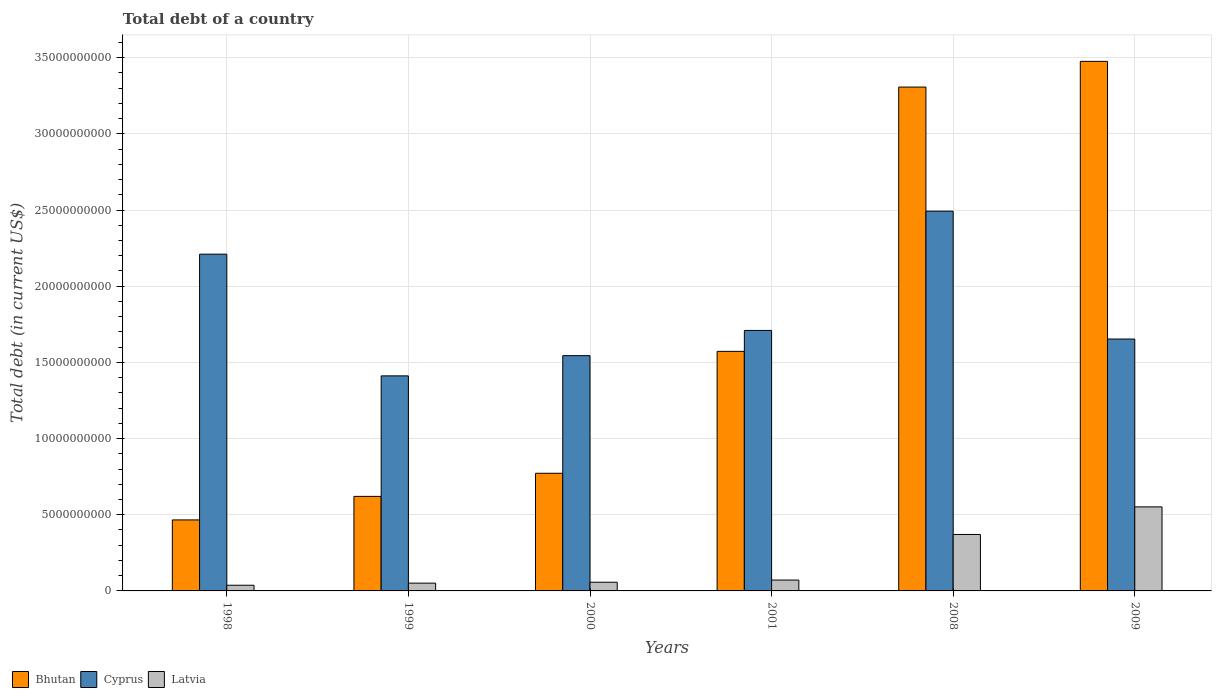How many different coloured bars are there?
Your answer should be very brief. 3. Are the number of bars per tick equal to the number of legend labels?
Your answer should be compact. Yes. How many bars are there on the 1st tick from the left?
Your answer should be compact. 3. How many bars are there on the 4th tick from the right?
Offer a very short reply. 3. What is the debt in Bhutan in 2008?
Keep it short and to the point. 3.31e+1. Across all years, what is the maximum debt in Latvia?
Give a very brief answer. 5.52e+09. Across all years, what is the minimum debt in Bhutan?
Provide a short and direct response. 4.66e+09. In which year was the debt in Bhutan maximum?
Offer a very short reply. 2009. In which year was the debt in Cyprus minimum?
Offer a terse response. 1999. What is the total debt in Bhutan in the graph?
Give a very brief answer. 1.02e+11. What is the difference between the debt in Latvia in 2000 and that in 2001?
Offer a terse response. -1.42e+08. What is the difference between the debt in Latvia in 2001 and the debt in Cyprus in 2009?
Give a very brief answer. -1.58e+1. What is the average debt in Cyprus per year?
Your response must be concise. 1.84e+1. In the year 2008, what is the difference between the debt in Bhutan and debt in Latvia?
Your answer should be compact. 2.94e+1. What is the ratio of the debt in Bhutan in 2001 to that in 2009?
Provide a succinct answer. 0.45. Is the difference between the debt in Bhutan in 2000 and 2001 greater than the difference between the debt in Latvia in 2000 and 2001?
Provide a succinct answer. No. What is the difference between the highest and the second highest debt in Bhutan?
Your answer should be compact. 1.69e+09. What is the difference between the highest and the lowest debt in Latvia?
Offer a very short reply. 5.14e+09. In how many years, is the debt in Cyprus greater than the average debt in Cyprus taken over all years?
Your response must be concise. 2. What does the 1st bar from the left in 2008 represents?
Keep it short and to the point. Bhutan. What does the 2nd bar from the right in 1999 represents?
Your answer should be very brief. Cyprus. How many bars are there?
Your answer should be very brief. 18. Are all the bars in the graph horizontal?
Make the answer very short. No. What is the difference between two consecutive major ticks on the Y-axis?
Make the answer very short. 5.00e+09. Does the graph contain any zero values?
Keep it short and to the point. No. Where does the legend appear in the graph?
Your answer should be very brief. Bottom left. How many legend labels are there?
Make the answer very short. 3. How are the legend labels stacked?
Provide a short and direct response. Horizontal. What is the title of the graph?
Ensure brevity in your answer.  Total debt of a country. What is the label or title of the Y-axis?
Your answer should be very brief. Total debt (in current US$). What is the Total debt (in current US$) of Bhutan in 1998?
Ensure brevity in your answer.  4.66e+09. What is the Total debt (in current US$) of Cyprus in 1998?
Keep it short and to the point. 2.21e+1. What is the Total debt (in current US$) of Latvia in 1998?
Give a very brief answer. 3.73e+08. What is the Total debt (in current US$) of Bhutan in 1999?
Offer a very short reply. 6.21e+09. What is the Total debt (in current US$) in Cyprus in 1999?
Provide a succinct answer. 1.41e+1. What is the Total debt (in current US$) of Latvia in 1999?
Your response must be concise. 5.11e+08. What is the Total debt (in current US$) in Bhutan in 2000?
Provide a short and direct response. 7.72e+09. What is the Total debt (in current US$) in Cyprus in 2000?
Provide a short and direct response. 1.54e+1. What is the Total debt (in current US$) of Latvia in 2000?
Provide a succinct answer. 5.71e+08. What is the Total debt (in current US$) in Bhutan in 2001?
Offer a terse response. 1.57e+1. What is the Total debt (in current US$) of Cyprus in 2001?
Your answer should be very brief. 1.71e+1. What is the Total debt (in current US$) of Latvia in 2001?
Give a very brief answer. 7.13e+08. What is the Total debt (in current US$) of Bhutan in 2008?
Make the answer very short. 3.31e+1. What is the Total debt (in current US$) of Cyprus in 2008?
Provide a succinct answer. 2.49e+1. What is the Total debt (in current US$) of Latvia in 2008?
Your response must be concise. 3.71e+09. What is the Total debt (in current US$) in Bhutan in 2009?
Your answer should be compact. 3.48e+1. What is the Total debt (in current US$) in Cyprus in 2009?
Give a very brief answer. 1.65e+1. What is the Total debt (in current US$) in Latvia in 2009?
Give a very brief answer. 5.52e+09. Across all years, what is the maximum Total debt (in current US$) in Bhutan?
Your answer should be compact. 3.48e+1. Across all years, what is the maximum Total debt (in current US$) of Cyprus?
Your answer should be compact. 2.49e+1. Across all years, what is the maximum Total debt (in current US$) of Latvia?
Give a very brief answer. 5.52e+09. Across all years, what is the minimum Total debt (in current US$) in Bhutan?
Your answer should be compact. 4.66e+09. Across all years, what is the minimum Total debt (in current US$) of Cyprus?
Keep it short and to the point. 1.41e+1. Across all years, what is the minimum Total debt (in current US$) in Latvia?
Offer a very short reply. 3.73e+08. What is the total Total debt (in current US$) of Bhutan in the graph?
Your answer should be compact. 1.02e+11. What is the total Total debt (in current US$) in Cyprus in the graph?
Your answer should be compact. 1.10e+11. What is the total Total debt (in current US$) of Latvia in the graph?
Give a very brief answer. 1.14e+1. What is the difference between the Total debt (in current US$) in Bhutan in 1998 and that in 1999?
Make the answer very short. -1.54e+09. What is the difference between the Total debt (in current US$) of Cyprus in 1998 and that in 1999?
Keep it short and to the point. 7.99e+09. What is the difference between the Total debt (in current US$) in Latvia in 1998 and that in 1999?
Keep it short and to the point. -1.38e+08. What is the difference between the Total debt (in current US$) of Bhutan in 1998 and that in 2000?
Provide a succinct answer. -3.06e+09. What is the difference between the Total debt (in current US$) in Cyprus in 1998 and that in 2000?
Give a very brief answer. 6.66e+09. What is the difference between the Total debt (in current US$) in Latvia in 1998 and that in 2000?
Provide a succinct answer. -1.98e+08. What is the difference between the Total debt (in current US$) of Bhutan in 1998 and that in 2001?
Your response must be concise. -1.11e+1. What is the difference between the Total debt (in current US$) of Cyprus in 1998 and that in 2001?
Your response must be concise. 5.01e+09. What is the difference between the Total debt (in current US$) of Latvia in 1998 and that in 2001?
Ensure brevity in your answer.  -3.40e+08. What is the difference between the Total debt (in current US$) of Bhutan in 1998 and that in 2008?
Your answer should be compact. -2.84e+1. What is the difference between the Total debt (in current US$) of Cyprus in 1998 and that in 2008?
Provide a succinct answer. -2.82e+09. What is the difference between the Total debt (in current US$) of Latvia in 1998 and that in 2008?
Your answer should be compact. -3.33e+09. What is the difference between the Total debt (in current US$) in Bhutan in 1998 and that in 2009?
Your answer should be compact. -3.01e+1. What is the difference between the Total debt (in current US$) in Cyprus in 1998 and that in 2009?
Your response must be concise. 5.57e+09. What is the difference between the Total debt (in current US$) in Latvia in 1998 and that in 2009?
Make the answer very short. -5.14e+09. What is the difference between the Total debt (in current US$) in Bhutan in 1999 and that in 2000?
Keep it short and to the point. -1.52e+09. What is the difference between the Total debt (in current US$) of Cyprus in 1999 and that in 2000?
Your answer should be very brief. -1.33e+09. What is the difference between the Total debt (in current US$) of Latvia in 1999 and that in 2000?
Make the answer very short. -6.02e+07. What is the difference between the Total debt (in current US$) in Bhutan in 1999 and that in 2001?
Provide a short and direct response. -9.52e+09. What is the difference between the Total debt (in current US$) in Cyprus in 1999 and that in 2001?
Provide a short and direct response. -2.98e+09. What is the difference between the Total debt (in current US$) of Latvia in 1999 and that in 2001?
Your answer should be very brief. -2.02e+08. What is the difference between the Total debt (in current US$) of Bhutan in 1999 and that in 2008?
Your answer should be compact. -2.69e+1. What is the difference between the Total debt (in current US$) of Cyprus in 1999 and that in 2008?
Offer a terse response. -1.08e+1. What is the difference between the Total debt (in current US$) in Latvia in 1999 and that in 2008?
Give a very brief answer. -3.20e+09. What is the difference between the Total debt (in current US$) of Bhutan in 1999 and that in 2009?
Your answer should be compact. -2.86e+1. What is the difference between the Total debt (in current US$) of Cyprus in 1999 and that in 2009?
Give a very brief answer. -2.42e+09. What is the difference between the Total debt (in current US$) of Latvia in 1999 and that in 2009?
Your answer should be compact. -5.01e+09. What is the difference between the Total debt (in current US$) in Bhutan in 2000 and that in 2001?
Your answer should be compact. -8.00e+09. What is the difference between the Total debt (in current US$) in Cyprus in 2000 and that in 2001?
Make the answer very short. -1.66e+09. What is the difference between the Total debt (in current US$) in Latvia in 2000 and that in 2001?
Offer a very short reply. -1.42e+08. What is the difference between the Total debt (in current US$) in Bhutan in 2000 and that in 2008?
Your response must be concise. -2.53e+1. What is the difference between the Total debt (in current US$) of Cyprus in 2000 and that in 2008?
Your answer should be compact. -9.48e+09. What is the difference between the Total debt (in current US$) in Latvia in 2000 and that in 2008?
Your response must be concise. -3.14e+09. What is the difference between the Total debt (in current US$) of Bhutan in 2000 and that in 2009?
Ensure brevity in your answer.  -2.70e+1. What is the difference between the Total debt (in current US$) in Cyprus in 2000 and that in 2009?
Ensure brevity in your answer.  -1.09e+09. What is the difference between the Total debt (in current US$) in Latvia in 2000 and that in 2009?
Make the answer very short. -4.95e+09. What is the difference between the Total debt (in current US$) of Bhutan in 2001 and that in 2008?
Your answer should be compact. -1.73e+1. What is the difference between the Total debt (in current US$) of Cyprus in 2001 and that in 2008?
Your response must be concise. -7.83e+09. What is the difference between the Total debt (in current US$) in Latvia in 2001 and that in 2008?
Offer a very short reply. -2.99e+09. What is the difference between the Total debt (in current US$) in Bhutan in 2001 and that in 2009?
Your answer should be very brief. -1.90e+1. What is the difference between the Total debt (in current US$) of Cyprus in 2001 and that in 2009?
Make the answer very short. 5.64e+08. What is the difference between the Total debt (in current US$) of Latvia in 2001 and that in 2009?
Keep it short and to the point. -4.80e+09. What is the difference between the Total debt (in current US$) of Bhutan in 2008 and that in 2009?
Your answer should be very brief. -1.69e+09. What is the difference between the Total debt (in current US$) in Cyprus in 2008 and that in 2009?
Ensure brevity in your answer.  8.39e+09. What is the difference between the Total debt (in current US$) in Latvia in 2008 and that in 2009?
Ensure brevity in your answer.  -1.81e+09. What is the difference between the Total debt (in current US$) of Bhutan in 1998 and the Total debt (in current US$) of Cyprus in 1999?
Ensure brevity in your answer.  -9.45e+09. What is the difference between the Total debt (in current US$) of Bhutan in 1998 and the Total debt (in current US$) of Latvia in 1999?
Provide a succinct answer. 4.15e+09. What is the difference between the Total debt (in current US$) in Cyprus in 1998 and the Total debt (in current US$) in Latvia in 1999?
Offer a terse response. 2.16e+1. What is the difference between the Total debt (in current US$) of Bhutan in 1998 and the Total debt (in current US$) of Cyprus in 2000?
Make the answer very short. -1.08e+1. What is the difference between the Total debt (in current US$) of Bhutan in 1998 and the Total debt (in current US$) of Latvia in 2000?
Offer a terse response. 4.09e+09. What is the difference between the Total debt (in current US$) of Cyprus in 1998 and the Total debt (in current US$) of Latvia in 2000?
Offer a very short reply. 2.15e+1. What is the difference between the Total debt (in current US$) in Bhutan in 1998 and the Total debt (in current US$) in Cyprus in 2001?
Your answer should be very brief. -1.24e+1. What is the difference between the Total debt (in current US$) in Bhutan in 1998 and the Total debt (in current US$) in Latvia in 2001?
Provide a succinct answer. 3.95e+09. What is the difference between the Total debt (in current US$) of Cyprus in 1998 and the Total debt (in current US$) of Latvia in 2001?
Make the answer very short. 2.14e+1. What is the difference between the Total debt (in current US$) in Bhutan in 1998 and the Total debt (in current US$) in Cyprus in 2008?
Keep it short and to the point. -2.03e+1. What is the difference between the Total debt (in current US$) of Bhutan in 1998 and the Total debt (in current US$) of Latvia in 2008?
Offer a terse response. 9.55e+08. What is the difference between the Total debt (in current US$) in Cyprus in 1998 and the Total debt (in current US$) in Latvia in 2008?
Your answer should be compact. 1.84e+1. What is the difference between the Total debt (in current US$) in Bhutan in 1998 and the Total debt (in current US$) in Cyprus in 2009?
Offer a very short reply. -1.19e+1. What is the difference between the Total debt (in current US$) in Bhutan in 1998 and the Total debt (in current US$) in Latvia in 2009?
Provide a short and direct response. -8.55e+08. What is the difference between the Total debt (in current US$) in Cyprus in 1998 and the Total debt (in current US$) in Latvia in 2009?
Offer a terse response. 1.66e+1. What is the difference between the Total debt (in current US$) in Bhutan in 1999 and the Total debt (in current US$) in Cyprus in 2000?
Offer a terse response. -9.24e+09. What is the difference between the Total debt (in current US$) in Bhutan in 1999 and the Total debt (in current US$) in Latvia in 2000?
Make the answer very short. 5.63e+09. What is the difference between the Total debt (in current US$) of Cyprus in 1999 and the Total debt (in current US$) of Latvia in 2000?
Your response must be concise. 1.35e+1. What is the difference between the Total debt (in current US$) of Bhutan in 1999 and the Total debt (in current US$) of Cyprus in 2001?
Offer a terse response. -1.09e+1. What is the difference between the Total debt (in current US$) of Bhutan in 1999 and the Total debt (in current US$) of Latvia in 2001?
Ensure brevity in your answer.  5.49e+09. What is the difference between the Total debt (in current US$) in Cyprus in 1999 and the Total debt (in current US$) in Latvia in 2001?
Your answer should be very brief. 1.34e+1. What is the difference between the Total debt (in current US$) in Bhutan in 1999 and the Total debt (in current US$) in Cyprus in 2008?
Offer a very short reply. -1.87e+1. What is the difference between the Total debt (in current US$) of Bhutan in 1999 and the Total debt (in current US$) of Latvia in 2008?
Offer a terse response. 2.50e+09. What is the difference between the Total debt (in current US$) in Cyprus in 1999 and the Total debt (in current US$) in Latvia in 2008?
Keep it short and to the point. 1.04e+1. What is the difference between the Total debt (in current US$) in Bhutan in 1999 and the Total debt (in current US$) in Cyprus in 2009?
Your answer should be very brief. -1.03e+1. What is the difference between the Total debt (in current US$) of Bhutan in 1999 and the Total debt (in current US$) of Latvia in 2009?
Provide a short and direct response. 6.89e+08. What is the difference between the Total debt (in current US$) in Cyprus in 1999 and the Total debt (in current US$) in Latvia in 2009?
Provide a succinct answer. 8.60e+09. What is the difference between the Total debt (in current US$) in Bhutan in 2000 and the Total debt (in current US$) in Cyprus in 2001?
Offer a very short reply. -9.38e+09. What is the difference between the Total debt (in current US$) of Bhutan in 2000 and the Total debt (in current US$) of Latvia in 2001?
Your answer should be compact. 7.01e+09. What is the difference between the Total debt (in current US$) of Cyprus in 2000 and the Total debt (in current US$) of Latvia in 2001?
Give a very brief answer. 1.47e+1. What is the difference between the Total debt (in current US$) of Bhutan in 2000 and the Total debt (in current US$) of Cyprus in 2008?
Give a very brief answer. -1.72e+1. What is the difference between the Total debt (in current US$) in Bhutan in 2000 and the Total debt (in current US$) in Latvia in 2008?
Your response must be concise. 4.02e+09. What is the difference between the Total debt (in current US$) of Cyprus in 2000 and the Total debt (in current US$) of Latvia in 2008?
Your answer should be very brief. 1.17e+1. What is the difference between the Total debt (in current US$) of Bhutan in 2000 and the Total debt (in current US$) of Cyprus in 2009?
Ensure brevity in your answer.  -8.81e+09. What is the difference between the Total debt (in current US$) in Bhutan in 2000 and the Total debt (in current US$) in Latvia in 2009?
Keep it short and to the point. 2.21e+09. What is the difference between the Total debt (in current US$) in Cyprus in 2000 and the Total debt (in current US$) in Latvia in 2009?
Provide a short and direct response. 9.93e+09. What is the difference between the Total debt (in current US$) in Bhutan in 2001 and the Total debt (in current US$) in Cyprus in 2008?
Keep it short and to the point. -9.20e+09. What is the difference between the Total debt (in current US$) of Bhutan in 2001 and the Total debt (in current US$) of Latvia in 2008?
Keep it short and to the point. 1.20e+1. What is the difference between the Total debt (in current US$) of Cyprus in 2001 and the Total debt (in current US$) of Latvia in 2008?
Your answer should be very brief. 1.34e+1. What is the difference between the Total debt (in current US$) in Bhutan in 2001 and the Total debt (in current US$) in Cyprus in 2009?
Provide a succinct answer. -8.10e+08. What is the difference between the Total debt (in current US$) in Bhutan in 2001 and the Total debt (in current US$) in Latvia in 2009?
Your answer should be compact. 1.02e+1. What is the difference between the Total debt (in current US$) of Cyprus in 2001 and the Total debt (in current US$) of Latvia in 2009?
Ensure brevity in your answer.  1.16e+1. What is the difference between the Total debt (in current US$) in Bhutan in 2008 and the Total debt (in current US$) in Cyprus in 2009?
Offer a terse response. 1.65e+1. What is the difference between the Total debt (in current US$) of Bhutan in 2008 and the Total debt (in current US$) of Latvia in 2009?
Provide a succinct answer. 2.76e+1. What is the difference between the Total debt (in current US$) in Cyprus in 2008 and the Total debt (in current US$) in Latvia in 2009?
Your response must be concise. 1.94e+1. What is the average Total debt (in current US$) of Bhutan per year?
Your response must be concise. 1.70e+1. What is the average Total debt (in current US$) in Cyprus per year?
Give a very brief answer. 1.84e+1. What is the average Total debt (in current US$) in Latvia per year?
Offer a very short reply. 1.90e+09. In the year 1998, what is the difference between the Total debt (in current US$) of Bhutan and Total debt (in current US$) of Cyprus?
Offer a terse response. -1.74e+1. In the year 1998, what is the difference between the Total debt (in current US$) in Bhutan and Total debt (in current US$) in Latvia?
Provide a succinct answer. 4.29e+09. In the year 1998, what is the difference between the Total debt (in current US$) in Cyprus and Total debt (in current US$) in Latvia?
Ensure brevity in your answer.  2.17e+1. In the year 1999, what is the difference between the Total debt (in current US$) of Bhutan and Total debt (in current US$) of Cyprus?
Ensure brevity in your answer.  -7.91e+09. In the year 1999, what is the difference between the Total debt (in current US$) in Bhutan and Total debt (in current US$) in Latvia?
Your answer should be very brief. 5.69e+09. In the year 1999, what is the difference between the Total debt (in current US$) of Cyprus and Total debt (in current US$) of Latvia?
Your answer should be very brief. 1.36e+1. In the year 2000, what is the difference between the Total debt (in current US$) in Bhutan and Total debt (in current US$) in Cyprus?
Keep it short and to the point. -7.72e+09. In the year 2000, what is the difference between the Total debt (in current US$) of Bhutan and Total debt (in current US$) of Latvia?
Offer a terse response. 7.15e+09. In the year 2000, what is the difference between the Total debt (in current US$) in Cyprus and Total debt (in current US$) in Latvia?
Keep it short and to the point. 1.49e+1. In the year 2001, what is the difference between the Total debt (in current US$) of Bhutan and Total debt (in current US$) of Cyprus?
Offer a very short reply. -1.37e+09. In the year 2001, what is the difference between the Total debt (in current US$) of Bhutan and Total debt (in current US$) of Latvia?
Your answer should be compact. 1.50e+1. In the year 2001, what is the difference between the Total debt (in current US$) of Cyprus and Total debt (in current US$) of Latvia?
Provide a succinct answer. 1.64e+1. In the year 2008, what is the difference between the Total debt (in current US$) of Bhutan and Total debt (in current US$) of Cyprus?
Offer a terse response. 8.14e+09. In the year 2008, what is the difference between the Total debt (in current US$) of Bhutan and Total debt (in current US$) of Latvia?
Give a very brief answer. 2.94e+1. In the year 2008, what is the difference between the Total debt (in current US$) of Cyprus and Total debt (in current US$) of Latvia?
Provide a short and direct response. 2.12e+1. In the year 2009, what is the difference between the Total debt (in current US$) in Bhutan and Total debt (in current US$) in Cyprus?
Ensure brevity in your answer.  1.82e+1. In the year 2009, what is the difference between the Total debt (in current US$) in Bhutan and Total debt (in current US$) in Latvia?
Offer a very short reply. 2.92e+1. In the year 2009, what is the difference between the Total debt (in current US$) of Cyprus and Total debt (in current US$) of Latvia?
Your answer should be compact. 1.10e+1. What is the ratio of the Total debt (in current US$) of Bhutan in 1998 to that in 1999?
Offer a terse response. 0.75. What is the ratio of the Total debt (in current US$) of Cyprus in 1998 to that in 1999?
Provide a short and direct response. 1.57. What is the ratio of the Total debt (in current US$) of Latvia in 1998 to that in 1999?
Provide a short and direct response. 0.73. What is the ratio of the Total debt (in current US$) in Bhutan in 1998 to that in 2000?
Provide a succinct answer. 0.6. What is the ratio of the Total debt (in current US$) of Cyprus in 1998 to that in 2000?
Provide a short and direct response. 1.43. What is the ratio of the Total debt (in current US$) in Latvia in 1998 to that in 2000?
Your answer should be compact. 0.65. What is the ratio of the Total debt (in current US$) of Bhutan in 1998 to that in 2001?
Keep it short and to the point. 0.3. What is the ratio of the Total debt (in current US$) of Cyprus in 1998 to that in 2001?
Ensure brevity in your answer.  1.29. What is the ratio of the Total debt (in current US$) of Latvia in 1998 to that in 2001?
Provide a short and direct response. 0.52. What is the ratio of the Total debt (in current US$) of Bhutan in 1998 to that in 2008?
Make the answer very short. 0.14. What is the ratio of the Total debt (in current US$) in Cyprus in 1998 to that in 2008?
Make the answer very short. 0.89. What is the ratio of the Total debt (in current US$) of Latvia in 1998 to that in 2008?
Provide a short and direct response. 0.1. What is the ratio of the Total debt (in current US$) of Bhutan in 1998 to that in 2009?
Your answer should be very brief. 0.13. What is the ratio of the Total debt (in current US$) in Cyprus in 1998 to that in 2009?
Keep it short and to the point. 1.34. What is the ratio of the Total debt (in current US$) of Latvia in 1998 to that in 2009?
Your response must be concise. 0.07. What is the ratio of the Total debt (in current US$) in Bhutan in 1999 to that in 2000?
Your answer should be very brief. 0.8. What is the ratio of the Total debt (in current US$) in Cyprus in 1999 to that in 2000?
Give a very brief answer. 0.91. What is the ratio of the Total debt (in current US$) of Latvia in 1999 to that in 2000?
Keep it short and to the point. 0.89. What is the ratio of the Total debt (in current US$) in Bhutan in 1999 to that in 2001?
Ensure brevity in your answer.  0.39. What is the ratio of the Total debt (in current US$) of Cyprus in 1999 to that in 2001?
Offer a very short reply. 0.83. What is the ratio of the Total debt (in current US$) in Latvia in 1999 to that in 2001?
Provide a short and direct response. 0.72. What is the ratio of the Total debt (in current US$) in Bhutan in 1999 to that in 2008?
Ensure brevity in your answer.  0.19. What is the ratio of the Total debt (in current US$) in Cyprus in 1999 to that in 2008?
Your answer should be very brief. 0.57. What is the ratio of the Total debt (in current US$) in Latvia in 1999 to that in 2008?
Ensure brevity in your answer.  0.14. What is the ratio of the Total debt (in current US$) of Bhutan in 1999 to that in 2009?
Offer a terse response. 0.18. What is the ratio of the Total debt (in current US$) of Cyprus in 1999 to that in 2009?
Offer a terse response. 0.85. What is the ratio of the Total debt (in current US$) in Latvia in 1999 to that in 2009?
Provide a succinct answer. 0.09. What is the ratio of the Total debt (in current US$) of Bhutan in 2000 to that in 2001?
Keep it short and to the point. 0.49. What is the ratio of the Total debt (in current US$) in Cyprus in 2000 to that in 2001?
Your answer should be compact. 0.9. What is the ratio of the Total debt (in current US$) of Latvia in 2000 to that in 2001?
Your response must be concise. 0.8. What is the ratio of the Total debt (in current US$) in Bhutan in 2000 to that in 2008?
Make the answer very short. 0.23. What is the ratio of the Total debt (in current US$) in Cyprus in 2000 to that in 2008?
Your response must be concise. 0.62. What is the ratio of the Total debt (in current US$) of Latvia in 2000 to that in 2008?
Provide a succinct answer. 0.15. What is the ratio of the Total debt (in current US$) of Bhutan in 2000 to that in 2009?
Make the answer very short. 0.22. What is the ratio of the Total debt (in current US$) of Cyprus in 2000 to that in 2009?
Provide a short and direct response. 0.93. What is the ratio of the Total debt (in current US$) in Latvia in 2000 to that in 2009?
Your response must be concise. 0.1. What is the ratio of the Total debt (in current US$) in Bhutan in 2001 to that in 2008?
Keep it short and to the point. 0.48. What is the ratio of the Total debt (in current US$) of Cyprus in 2001 to that in 2008?
Provide a succinct answer. 0.69. What is the ratio of the Total debt (in current US$) of Latvia in 2001 to that in 2008?
Provide a succinct answer. 0.19. What is the ratio of the Total debt (in current US$) in Bhutan in 2001 to that in 2009?
Offer a terse response. 0.45. What is the ratio of the Total debt (in current US$) of Cyprus in 2001 to that in 2009?
Provide a short and direct response. 1.03. What is the ratio of the Total debt (in current US$) in Latvia in 2001 to that in 2009?
Make the answer very short. 0.13. What is the ratio of the Total debt (in current US$) in Bhutan in 2008 to that in 2009?
Provide a succinct answer. 0.95. What is the ratio of the Total debt (in current US$) in Cyprus in 2008 to that in 2009?
Your answer should be very brief. 1.51. What is the ratio of the Total debt (in current US$) in Latvia in 2008 to that in 2009?
Your answer should be very brief. 0.67. What is the difference between the highest and the second highest Total debt (in current US$) in Bhutan?
Keep it short and to the point. 1.69e+09. What is the difference between the highest and the second highest Total debt (in current US$) in Cyprus?
Provide a succinct answer. 2.82e+09. What is the difference between the highest and the second highest Total debt (in current US$) of Latvia?
Provide a short and direct response. 1.81e+09. What is the difference between the highest and the lowest Total debt (in current US$) of Bhutan?
Give a very brief answer. 3.01e+1. What is the difference between the highest and the lowest Total debt (in current US$) of Cyprus?
Your answer should be compact. 1.08e+1. What is the difference between the highest and the lowest Total debt (in current US$) of Latvia?
Provide a succinct answer. 5.14e+09. 